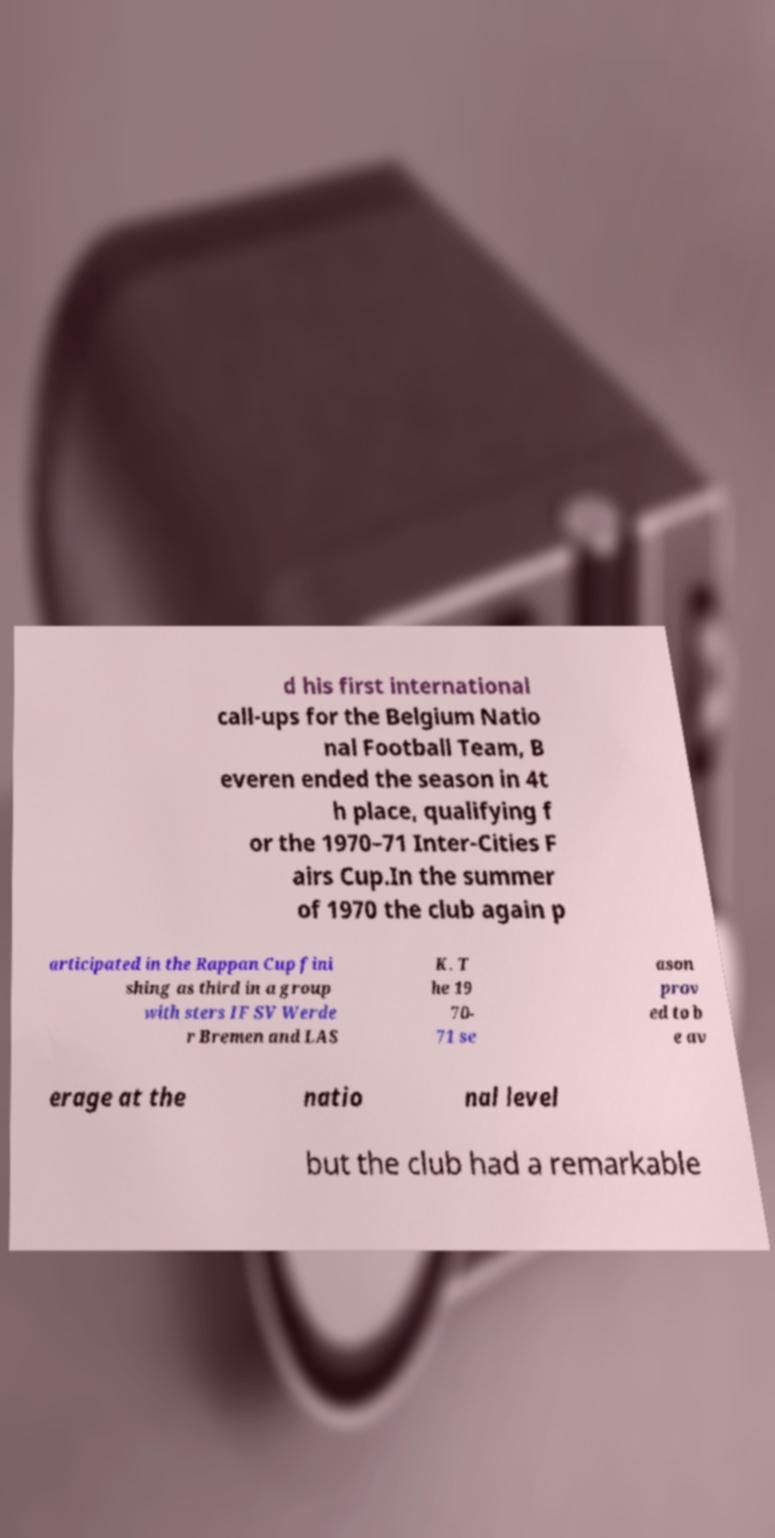Can you read and provide the text displayed in the image?This photo seems to have some interesting text. Can you extract and type it out for me? d his first international call-ups for the Belgium Natio nal Football Team, B everen ended the season in 4t h place, qualifying f or the 1970–71 Inter-Cities F airs Cup.In the summer of 1970 the club again p articipated in the Rappan Cup fini shing as third in a group with sters IF SV Werde r Bremen and LAS K. T he 19 70- 71 se ason prov ed to b e av erage at the natio nal level but the club had a remarkable 